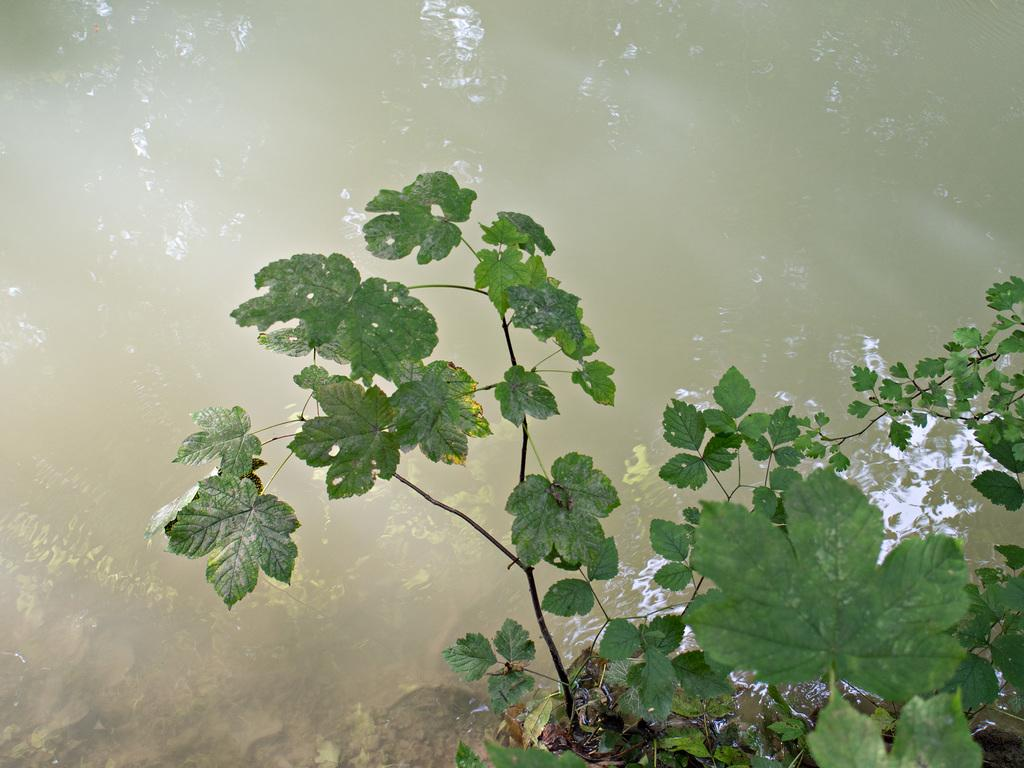What is present in the image? There is a plant and water visible in the image. Can you describe the plant in the image? Unfortunately, the facts provided do not give any details about the plant. What is the water doing in the image? The facts provided do not give any details about the water's purpose or action in the image. How many bells are hanging from the plant in the image? There are no bells present in the image. What is the arm of the person doing in the image? There is no person or arm present in the image. What season is depicted in the image? The facts provided do not give any details about the season or time of year. 